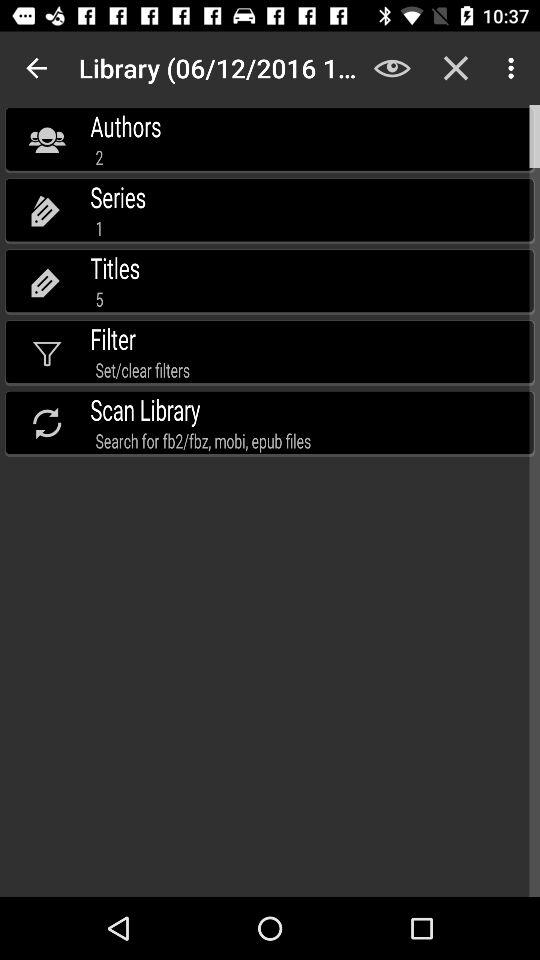What is the mentioned date of the library? The mentioned date of the library is June 12, 2016. 